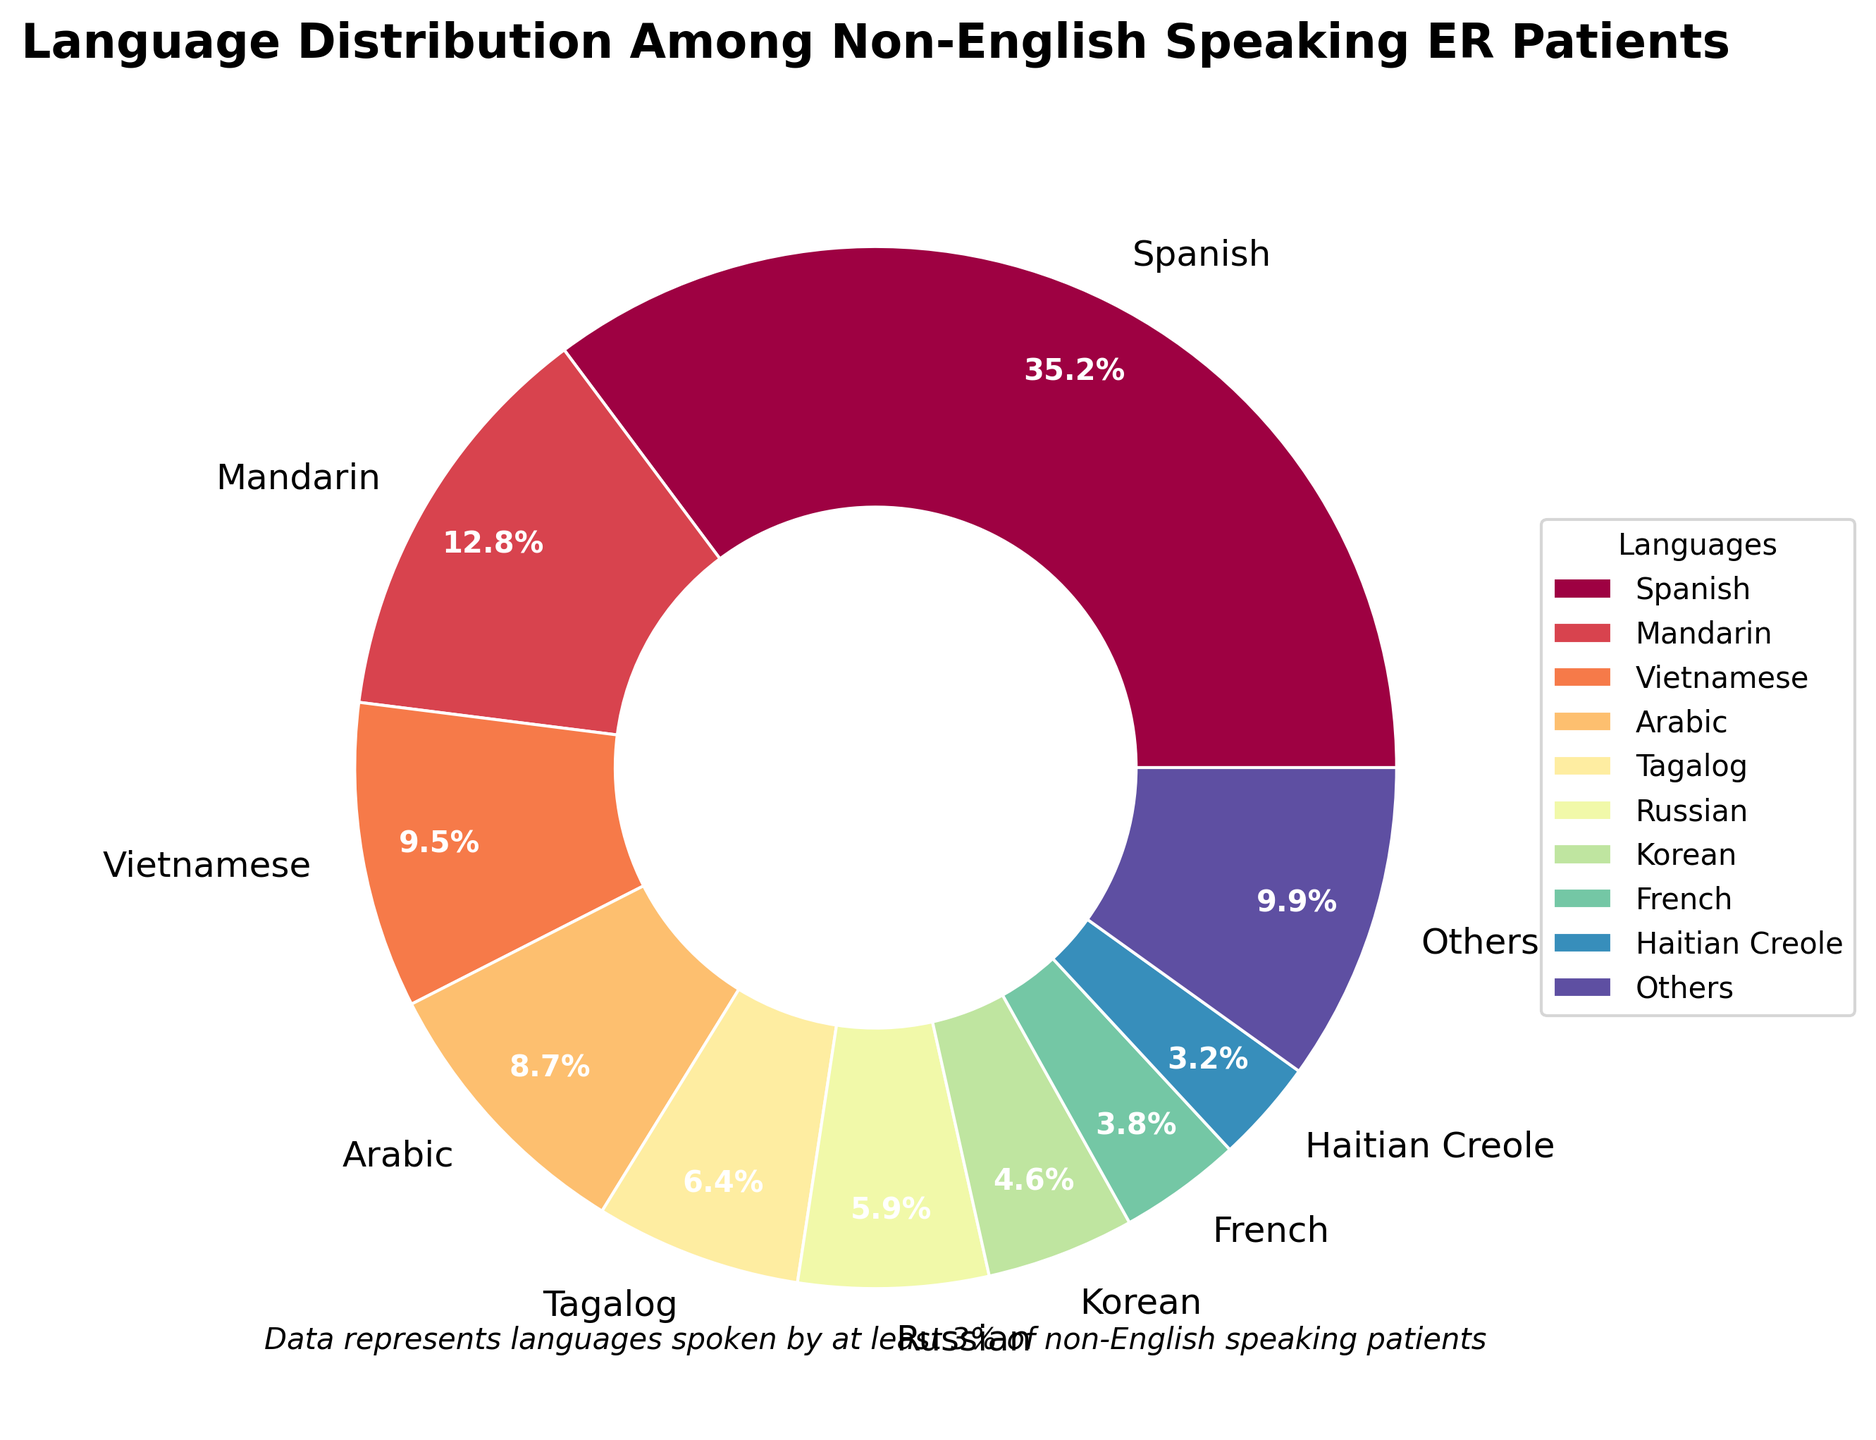What is the most spoken non-English language among ER patients according to the pie chart? The largest portion of the pie chart represents Spanish-speaking patients.
Answer: Spanish How many languages are represented by segments that are at least 3% of the distribution? In the pie chart, each segment has a label showing the percentage. Count the segments representing 3% or more.
Answer: 10 What is the combined percentage of patients speaking Spanish and Mandarin? Add the percentages of Spanish-speaking (35.2%) and Mandarin-speaking (12.8%) patients: 35.2 + 12.8 = 48.0%.
Answer: 48.0% Which is the least represented language among those that are at least 3%? Among the segments equal to or greater than 3%, identify the one with the smallest percentage, which is Haitian Creole (3.2%).
Answer: Haitian Creole How much higher is Spanish's percentage compared to Vietnamese's percentage? Subtract the Vietnamese percentage (9.5%) from the Spanish percentage (35.2%): 35.2 - 9.5 = 25.7%.
Answer: 25.7% Which languages have percentages greater than Tagalog's percentage? Identify the segments with percentages higher than Tagalog's (6.4%), which are Spanish (35.2%), Mandarin (12.8%), Vietnamese (9.5%), and Arabic (8.7%).
Answer: Spanish, Mandarin, Vietnamese, Arabic If you combine the percentages of Arabic, Tagalog, and Russian, is their combined percentage higher than Mandarin's? Add Arabic's (8.7%), Tagalog's (6.4%), and Russian's (5.9%) percentages: 8.7 + 6.4 + 5.9 = 21.0%, which is higher than Mandarin's 12.8%.
Answer: Yes List the languages that together form the "Others" category and their combined percentage. The "Others" category comprises languages with percentages less than 3%: Portuguese, Polish, Bengali, Urdu, and Cantonese. Combined, these total 9.9% (100% - 90.1%).
Answer: Portuguese, Polish, Bengali, Urdu, Cantonese; 9.9% What is the color of the segment representing the French language? The segment labeled "French" in the pie chart has a specific color based on the chart's palette, easily identifiable visually.
Answer: Determine by visual inspection of the figure How does the percentage of Korean-speaking patients compare to French-speaking patients? Compare the percentages labeled on the segments for Korean (4.6%) and French (3.8%): 4.6% is greater than 3.8%.
Answer: Korean-speaking is higher 